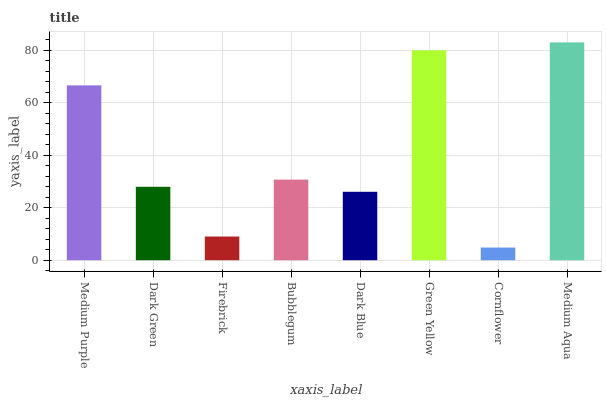Is Cornflower the minimum?
Answer yes or no. Yes. Is Medium Aqua the maximum?
Answer yes or no. Yes. Is Dark Green the minimum?
Answer yes or no. No. Is Dark Green the maximum?
Answer yes or no. No. Is Medium Purple greater than Dark Green?
Answer yes or no. Yes. Is Dark Green less than Medium Purple?
Answer yes or no. Yes. Is Dark Green greater than Medium Purple?
Answer yes or no. No. Is Medium Purple less than Dark Green?
Answer yes or no. No. Is Bubblegum the high median?
Answer yes or no. Yes. Is Dark Green the low median?
Answer yes or no. Yes. Is Dark Green the high median?
Answer yes or no. No. Is Cornflower the low median?
Answer yes or no. No. 